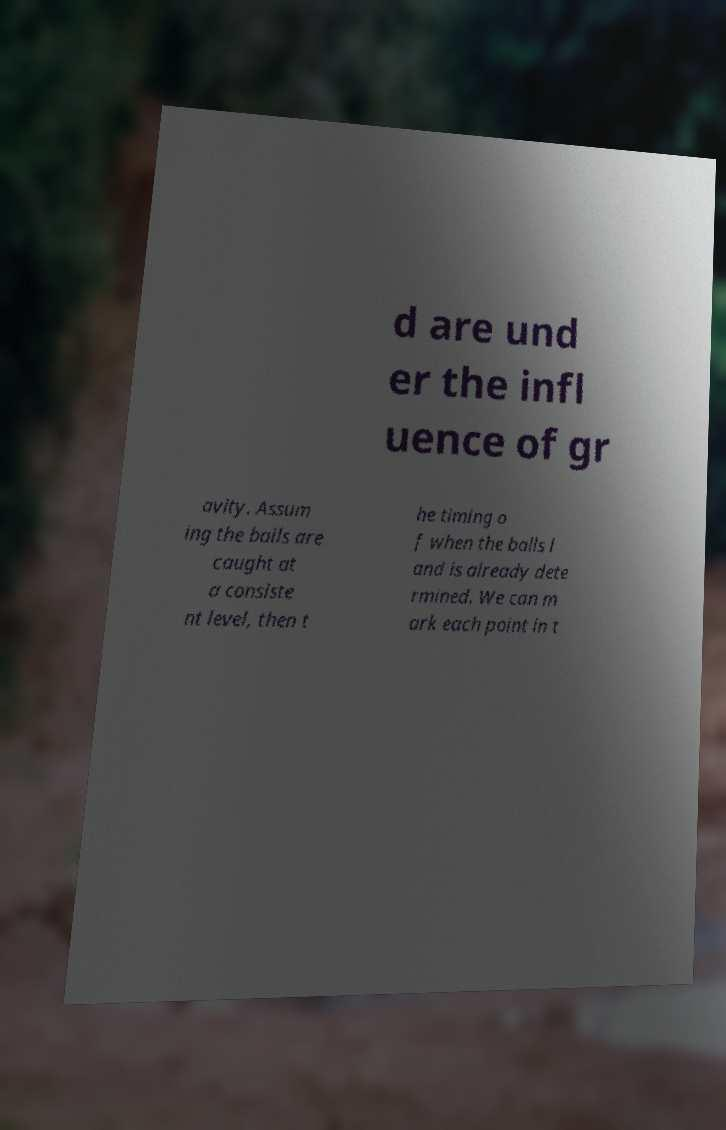Can you read and provide the text displayed in the image?This photo seems to have some interesting text. Can you extract and type it out for me? d are und er the infl uence of gr avity. Assum ing the balls are caught at a consiste nt level, then t he timing o f when the balls l and is already dete rmined. We can m ark each point in t 